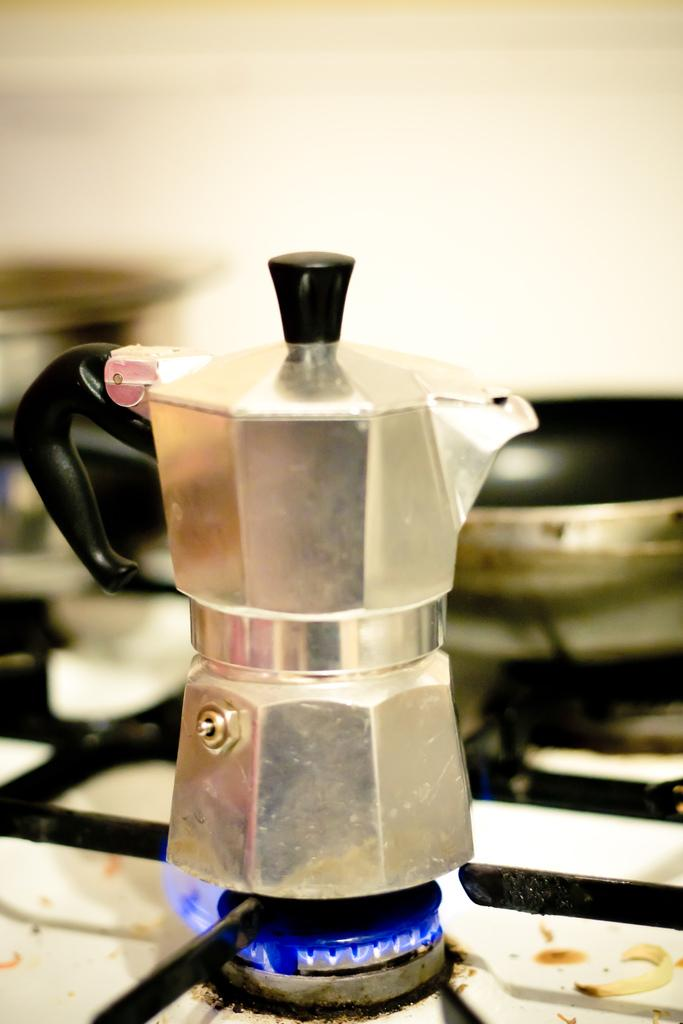What is placed on the stove in the image? There is a jar and a pan placed on the stove in the image. What might be the purpose of the jar and pan on the stove? The jar and pan on the stove might be used for cooking or heating food or liquids. How does the nail feel about being placed on the stove in the image? There is no nail present in the image, so it is not possible to determine how a nail might feel about being placed on the stove. 